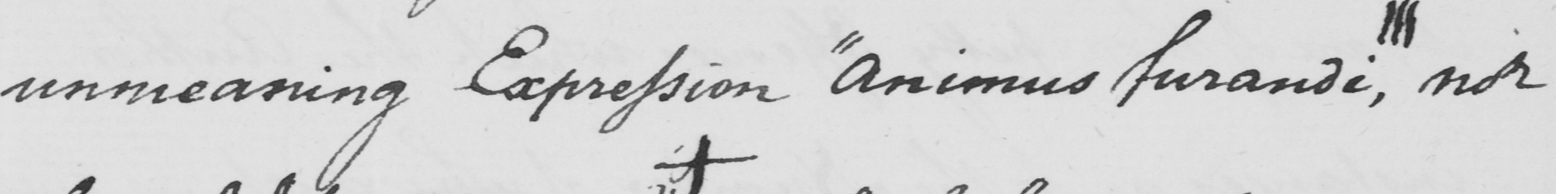What text is written in this handwritten line? unmeaning Expression  " animus furandi,||| nor 